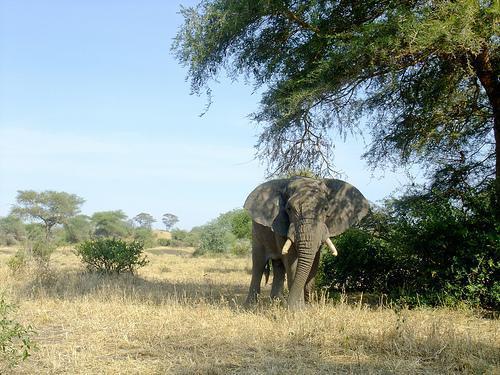How many elephants are there?
Give a very brief answer. 1. How many tusks does the elephant have?
Give a very brief answer. 2. 